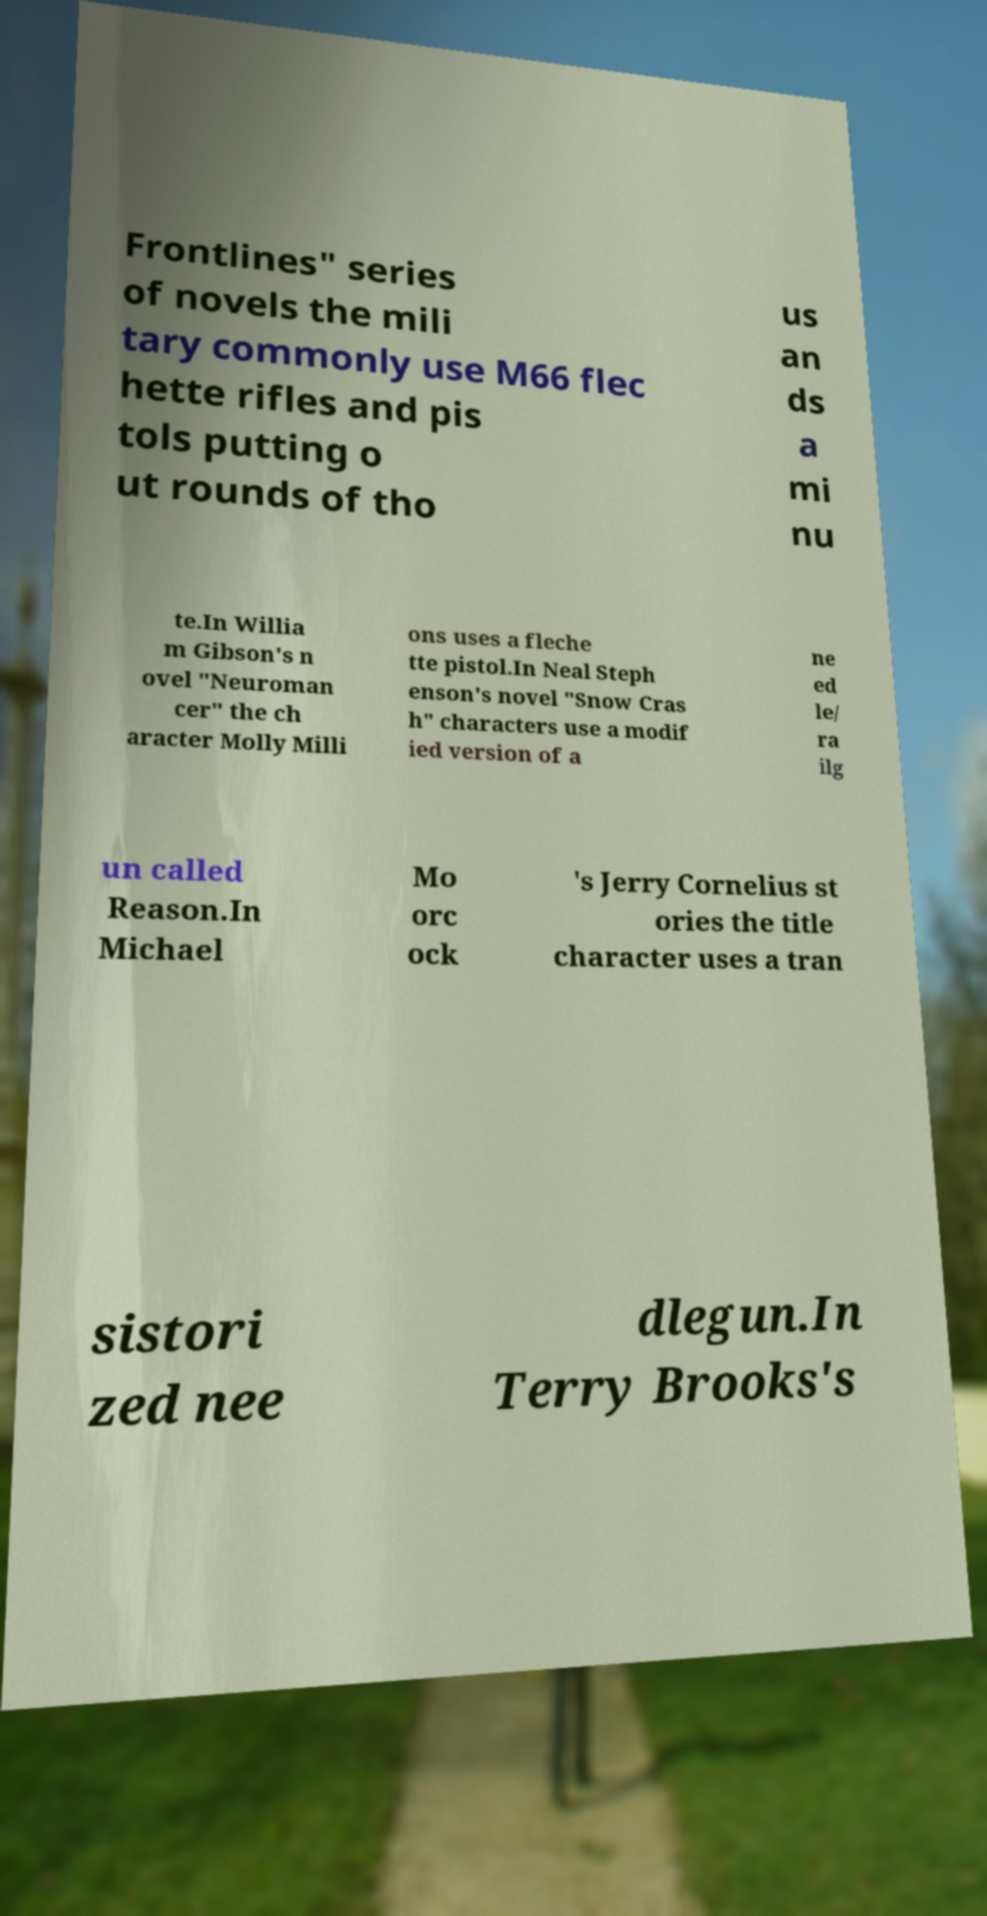Could you extract and type out the text from this image? Frontlines" series of novels the mili tary commonly use M66 flec hette rifles and pis tols putting o ut rounds of tho us an ds a mi nu te.In Willia m Gibson's n ovel "Neuroman cer" the ch aracter Molly Milli ons uses a fleche tte pistol.In Neal Steph enson's novel "Snow Cras h" characters use a modif ied version of a ne ed le/ ra ilg un called Reason.In Michael Mo orc ock 's Jerry Cornelius st ories the title character uses a tran sistori zed nee dlegun.In Terry Brooks's 